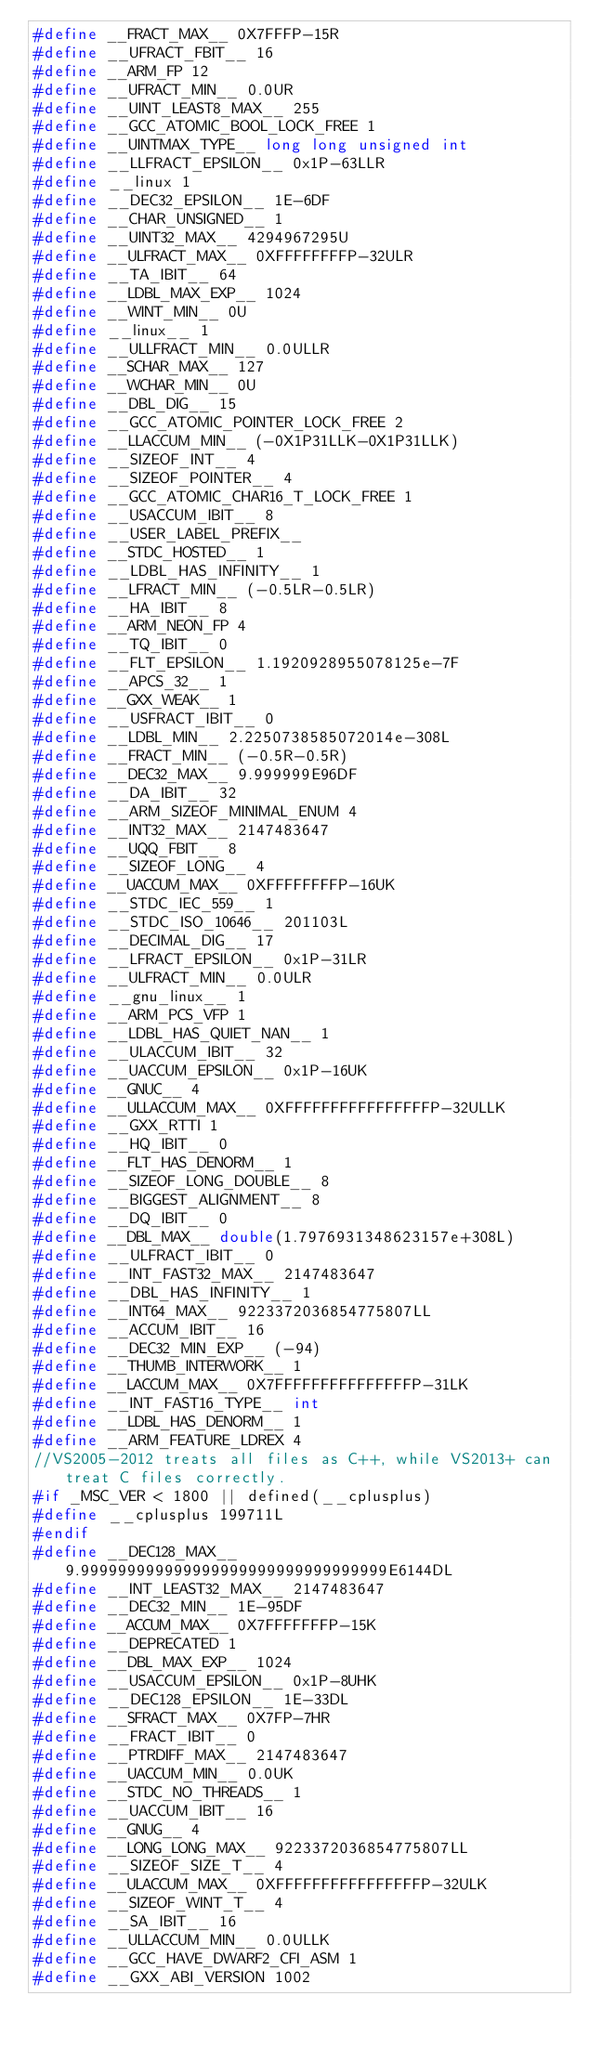<code> <loc_0><loc_0><loc_500><loc_500><_C_>#define __FRACT_MAX__ 0X7FFFP-15R
#define __UFRACT_FBIT__ 16
#define __ARM_FP 12
#define __UFRACT_MIN__ 0.0UR
#define __UINT_LEAST8_MAX__ 255
#define __GCC_ATOMIC_BOOL_LOCK_FREE 1
#define __UINTMAX_TYPE__ long long unsigned int
#define __LLFRACT_EPSILON__ 0x1P-63LLR
#define __linux 1
#define __DEC32_EPSILON__ 1E-6DF
#define __CHAR_UNSIGNED__ 1
#define __UINT32_MAX__ 4294967295U
#define __ULFRACT_MAX__ 0XFFFFFFFFP-32ULR
#define __TA_IBIT__ 64
#define __LDBL_MAX_EXP__ 1024
#define __WINT_MIN__ 0U
#define __linux__ 1
#define __ULLFRACT_MIN__ 0.0ULLR
#define __SCHAR_MAX__ 127
#define __WCHAR_MIN__ 0U
#define __DBL_DIG__ 15
#define __GCC_ATOMIC_POINTER_LOCK_FREE 2
#define __LLACCUM_MIN__ (-0X1P31LLK-0X1P31LLK)
#define __SIZEOF_INT__ 4
#define __SIZEOF_POINTER__ 4
#define __GCC_ATOMIC_CHAR16_T_LOCK_FREE 1
#define __USACCUM_IBIT__ 8
#define __USER_LABEL_PREFIX__ 
#define __STDC_HOSTED__ 1
#define __LDBL_HAS_INFINITY__ 1
#define __LFRACT_MIN__ (-0.5LR-0.5LR)
#define __HA_IBIT__ 8
#define __ARM_NEON_FP 4
#define __TQ_IBIT__ 0
#define __FLT_EPSILON__ 1.1920928955078125e-7F
#define __APCS_32__ 1
#define __GXX_WEAK__ 1
#define __USFRACT_IBIT__ 0
#define __LDBL_MIN__ 2.2250738585072014e-308L
#define __FRACT_MIN__ (-0.5R-0.5R)
#define __DEC32_MAX__ 9.999999E96DF
#define __DA_IBIT__ 32
#define __ARM_SIZEOF_MINIMAL_ENUM 4
#define __INT32_MAX__ 2147483647
#define __UQQ_FBIT__ 8
#define __SIZEOF_LONG__ 4
#define __UACCUM_MAX__ 0XFFFFFFFFP-16UK
#define __STDC_IEC_559__ 1
#define __STDC_ISO_10646__ 201103L
#define __DECIMAL_DIG__ 17
#define __LFRACT_EPSILON__ 0x1P-31LR
#define __ULFRACT_MIN__ 0.0ULR
#define __gnu_linux__ 1
#define __ARM_PCS_VFP 1
#define __LDBL_HAS_QUIET_NAN__ 1
#define __ULACCUM_IBIT__ 32
#define __UACCUM_EPSILON__ 0x1P-16UK
#define __GNUC__ 4
#define __ULLACCUM_MAX__ 0XFFFFFFFFFFFFFFFFP-32ULLK
#define __GXX_RTTI 1
#define __HQ_IBIT__ 0
#define __FLT_HAS_DENORM__ 1
#define __SIZEOF_LONG_DOUBLE__ 8
#define __BIGGEST_ALIGNMENT__ 8
#define __DQ_IBIT__ 0
#define __DBL_MAX__ double(1.7976931348623157e+308L)
#define __ULFRACT_IBIT__ 0
#define __INT_FAST32_MAX__ 2147483647
#define __DBL_HAS_INFINITY__ 1
#define __INT64_MAX__ 9223372036854775807LL
#define __ACCUM_IBIT__ 16
#define __DEC32_MIN_EXP__ (-94)
#define __THUMB_INTERWORK__ 1
#define __LACCUM_MAX__ 0X7FFFFFFFFFFFFFFFP-31LK
#define __INT_FAST16_TYPE__ int
#define __LDBL_HAS_DENORM__ 1
#define __ARM_FEATURE_LDREX 4
//VS2005-2012 treats all files as C++, while VS2013+ can treat C files correctly.
#if _MSC_VER < 1800 || defined(__cplusplus)
#define __cplusplus 199711L
#endif
#define __DEC128_MAX__ 9.999999999999999999999999999999999E6144DL
#define __INT_LEAST32_MAX__ 2147483647
#define __DEC32_MIN__ 1E-95DF
#define __ACCUM_MAX__ 0X7FFFFFFFP-15K
#define __DEPRECATED 1
#define __DBL_MAX_EXP__ 1024
#define __USACCUM_EPSILON__ 0x1P-8UHK
#define __DEC128_EPSILON__ 1E-33DL
#define __SFRACT_MAX__ 0X7FP-7HR
#define __FRACT_IBIT__ 0
#define __PTRDIFF_MAX__ 2147483647
#define __UACCUM_MIN__ 0.0UK
#define __STDC_NO_THREADS__ 1
#define __UACCUM_IBIT__ 16
#define __GNUG__ 4
#define __LONG_LONG_MAX__ 9223372036854775807LL
#define __SIZEOF_SIZE_T__ 4
#define __ULACCUM_MAX__ 0XFFFFFFFFFFFFFFFFP-32ULK
#define __SIZEOF_WINT_T__ 4
#define __SA_IBIT__ 16
#define __ULLACCUM_MIN__ 0.0ULLK
#define __GCC_HAVE_DWARF2_CFI_ASM 1
#define __GXX_ABI_VERSION 1002</code> 